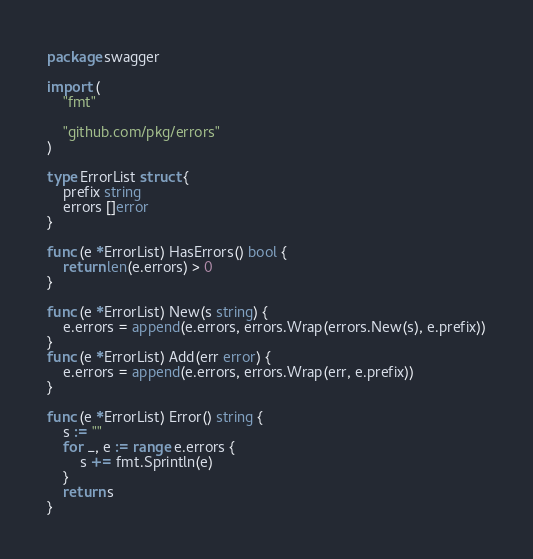<code> <loc_0><loc_0><loc_500><loc_500><_Go_>package swagger

import (
	"fmt"

	"github.com/pkg/errors"
)

type ErrorList struct {
	prefix string
	errors []error
}

func (e *ErrorList) HasErrors() bool {
	return len(e.errors) > 0
}

func (e *ErrorList) New(s string) {
	e.errors = append(e.errors, errors.Wrap(errors.New(s), e.prefix))
}
func (e *ErrorList) Add(err error) {
	e.errors = append(e.errors, errors.Wrap(err, e.prefix))
}

func (e *ErrorList) Error() string {
	s := ""
	for _, e := range e.errors {
		s += fmt.Sprintln(e)
	}
	return s
}
</code> 